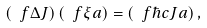Convert formula to latex. <formula><loc_0><loc_0><loc_500><loc_500>\left ( \ f { \Delta } { J } \right ) \left ( \ f { \xi } { a } \right ) = \left ( \ f { \hbar { c } } { J a } \right ) ,</formula> 